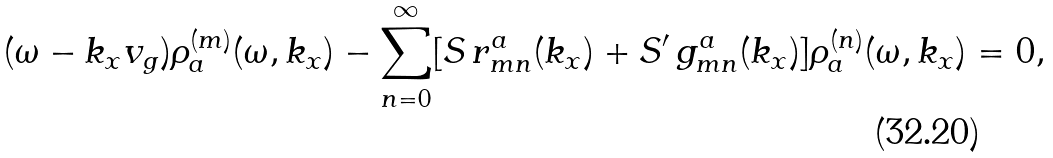<formula> <loc_0><loc_0><loc_500><loc_500>( \omega - k _ { x } v _ { g } ) \rho _ { a } ^ { ( m ) } ( \omega , k _ { x } ) - \sum _ { n = 0 } ^ { \infty } [ S \, r _ { m n } ^ { a } ( k _ { x } ) + S ^ { \prime } \, g _ { m n } ^ { a } ( k _ { x } ) ] \rho _ { a } ^ { ( n ) } ( \omega , k _ { x } ) = 0 ,</formula> 